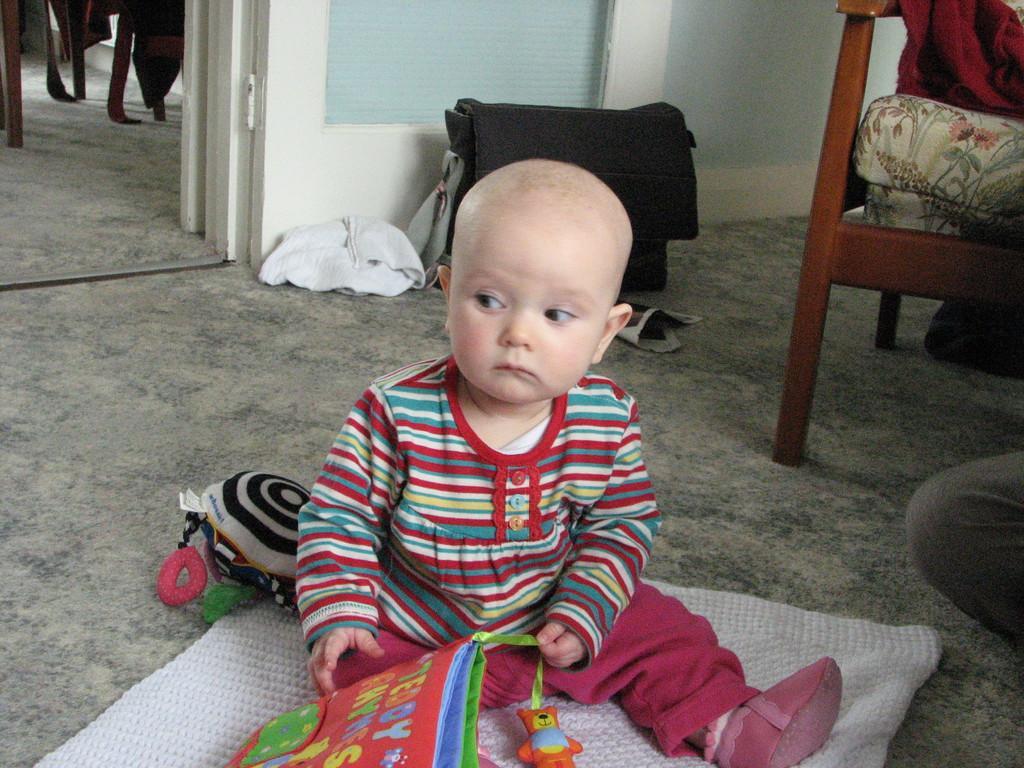Please provide a concise description of this image. In this image we can see there is a kid sat on the mat, in front of the kid there are toys, beside the kid there is another person and there is a wooden chair and there are few objects placed on the floor. In the background there is a wall and an open door. From the door, we can see some objects in the next room. 